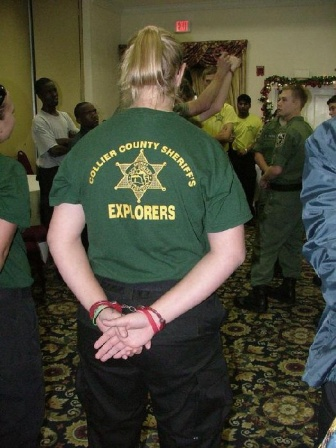Imagine if the image was part of a futuristic virtual reality training program. Describe what could be happening in this scenario. In a not-so-distant future, the room captured in the image exists within a state-of-the-art virtual reality training module. The individual in the forefront, donning the 'Collier County Sheriff's Explorers' t-shirt, is an avatar controlled by an experienced instructor. Recruits, represented by avatars in the background, engage in immersive scenarios designed to teach law enforcement tactics and community interaction. The festive decorations are part of a situational awareness exercise, emphasizing the importance of vigilance during public events. Participants navigate through multiple modules, simulating real-world challenges, from holiday security protocols to crowd management. The VR environment adapts to each decision made, offering real-time feedback and creating a dynamic, interactive learning experience. The main observer's stance mimics that of a thoughtful supervisor, overseeing the trainees' performance, ready to intervene and provide guidance through this high-tech platform. 